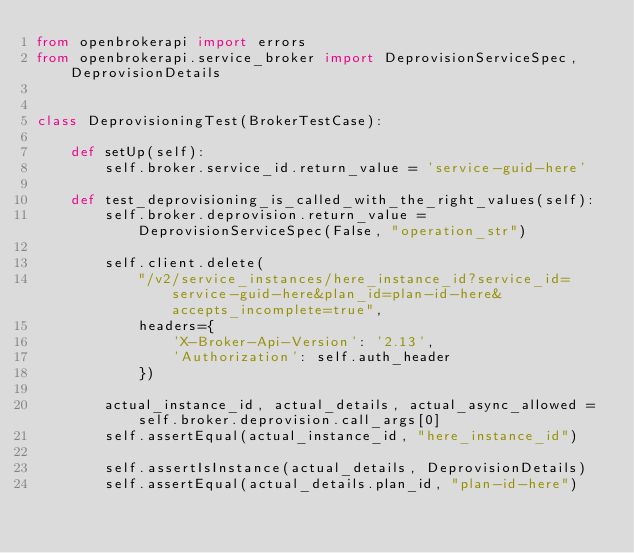<code> <loc_0><loc_0><loc_500><loc_500><_Python_>from openbrokerapi import errors
from openbrokerapi.service_broker import DeprovisionServiceSpec, DeprovisionDetails


class DeprovisioningTest(BrokerTestCase):

    def setUp(self):
        self.broker.service_id.return_value = 'service-guid-here'

    def test_deprovisioning_is_called_with_the_right_values(self):
        self.broker.deprovision.return_value = DeprovisionServiceSpec(False, "operation_str")

        self.client.delete(
            "/v2/service_instances/here_instance_id?service_id=service-guid-here&plan_id=plan-id-here&accepts_incomplete=true",
            headers={
                'X-Broker-Api-Version': '2.13',
                'Authorization': self.auth_header
            })

        actual_instance_id, actual_details, actual_async_allowed = self.broker.deprovision.call_args[0]
        self.assertEqual(actual_instance_id, "here_instance_id")

        self.assertIsInstance(actual_details, DeprovisionDetails)
        self.assertEqual(actual_details.plan_id, "plan-id-here")</code> 